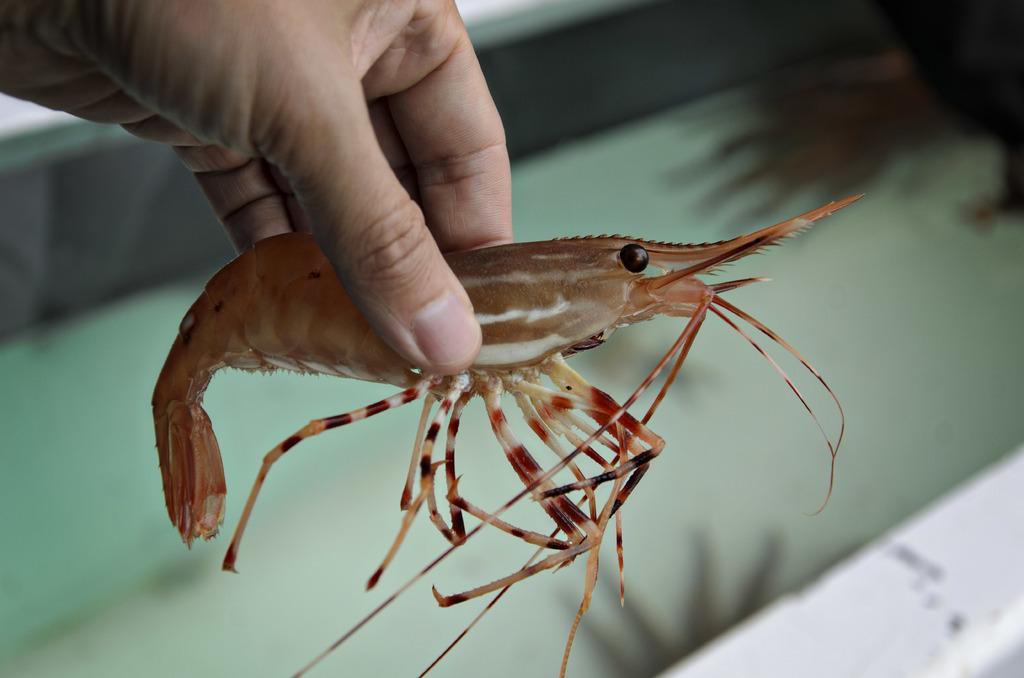How would you summarize this image in a sentence or two? In this image in the front there is a person holding a prawn in his hand and the background is blurry. 